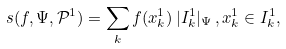<formula> <loc_0><loc_0><loc_500><loc_500>s ( f , \Psi , \mathcal { P } ^ { 1 } ) = \sum _ { k } f ( x _ { k } ^ { 1 } ) \, | I ^ { 1 } _ { k } | _ { \Psi } \, , x _ { k } ^ { 1 } \in I ^ { 1 } _ { k } ,</formula> 